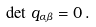Convert formula to latex. <formula><loc_0><loc_0><loc_500><loc_500>\det \, q _ { \alpha \beta } = 0 \, .</formula> 